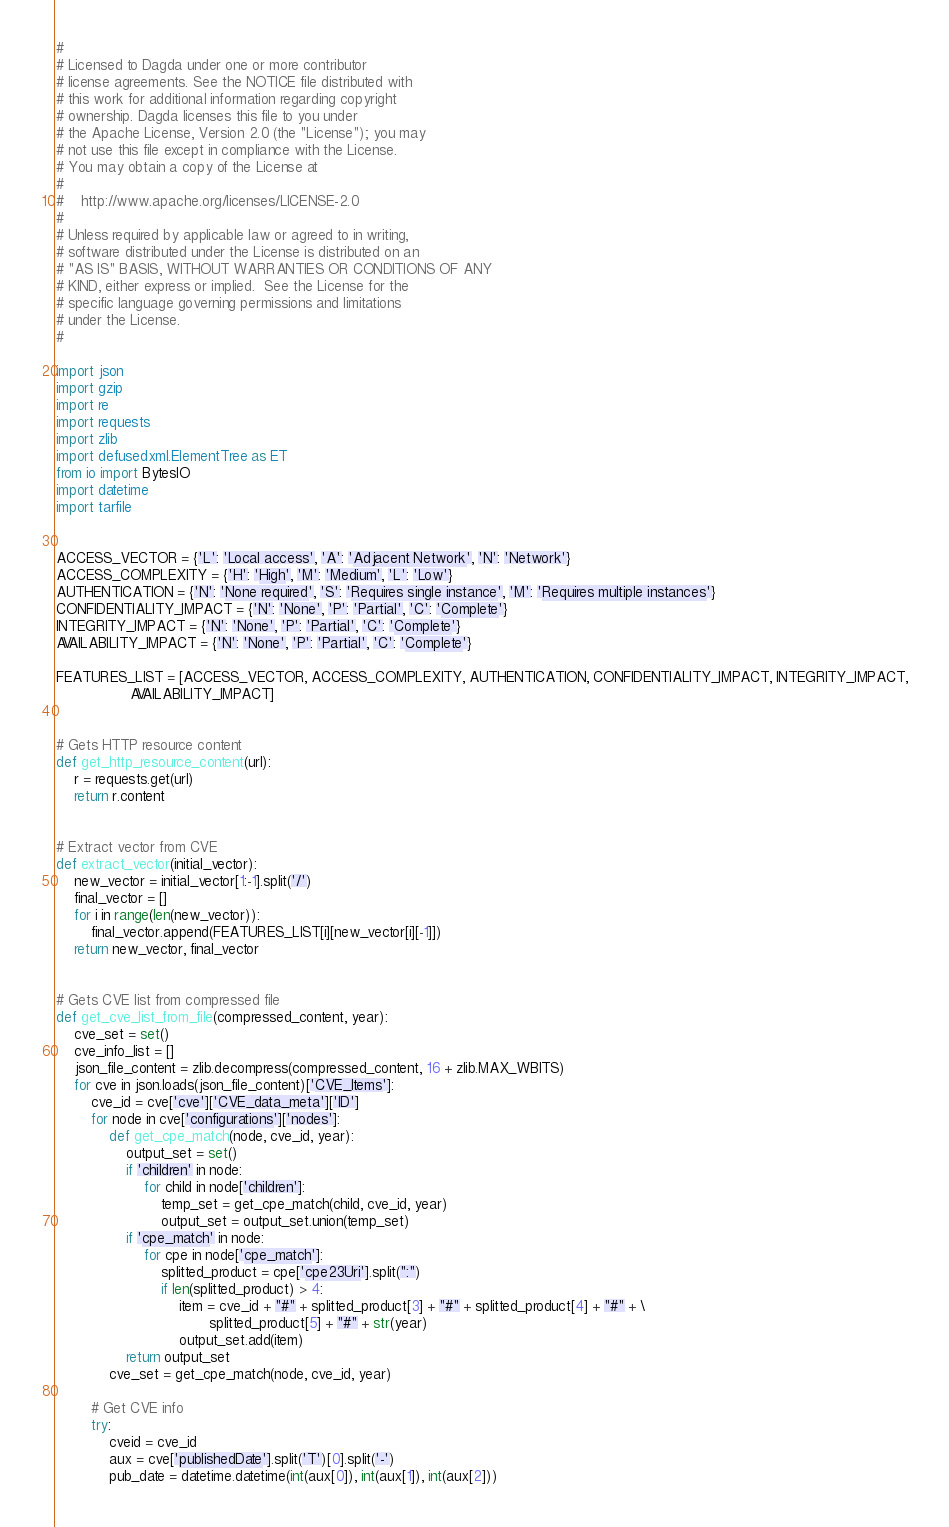Convert code to text. <code><loc_0><loc_0><loc_500><loc_500><_Python_>#
# Licensed to Dagda under one or more contributor
# license agreements. See the NOTICE file distributed with
# this work for additional information regarding copyright
# ownership. Dagda licenses this file to you under
# the Apache License, Version 2.0 (the "License"); you may
# not use this file except in compliance with the License.
# You may obtain a copy of the License at
#
#    http://www.apache.org/licenses/LICENSE-2.0
#
# Unless required by applicable law or agreed to in writing,
# software distributed under the License is distributed on an
# "AS IS" BASIS, WITHOUT WARRANTIES OR CONDITIONS OF ANY
# KIND, either express or implied.  See the License for the
# specific language governing permissions and limitations
# under the License.
#

import json
import gzip
import re
import requests
import zlib
import defusedxml.ElementTree as ET
from io import BytesIO
import datetime
import tarfile


ACCESS_VECTOR = {'L': 'Local access', 'A': 'Adjacent Network', 'N': 'Network'}
ACCESS_COMPLEXITY = {'H': 'High', 'M': 'Medium', 'L': 'Low'}
AUTHENTICATION = {'N': 'None required', 'S': 'Requires single instance', 'M': 'Requires multiple instances'}
CONFIDENTIALITY_IMPACT = {'N': 'None', 'P': 'Partial', 'C': 'Complete'}
INTEGRITY_IMPACT = {'N': 'None', 'P': 'Partial', 'C': 'Complete'}
AVAILABILITY_IMPACT = {'N': 'None', 'P': 'Partial', 'C': 'Complete'}

FEATURES_LIST = [ACCESS_VECTOR, ACCESS_COMPLEXITY, AUTHENTICATION, CONFIDENTIALITY_IMPACT, INTEGRITY_IMPACT,
                 AVAILABILITY_IMPACT]


# Gets HTTP resource content
def get_http_resource_content(url):
    r = requests.get(url)
    return r.content


# Extract vector from CVE
def extract_vector(initial_vector):
    new_vector = initial_vector[1:-1].split('/')
    final_vector = []
    for i in range(len(new_vector)):
        final_vector.append(FEATURES_LIST[i][new_vector[i][-1]])
    return new_vector, final_vector


# Gets CVE list from compressed file
def get_cve_list_from_file(compressed_content, year):
    cve_set = set()
    cve_info_list = []
    json_file_content = zlib.decompress(compressed_content, 16 + zlib.MAX_WBITS)
    for cve in json.loads(json_file_content)['CVE_Items']:
        cve_id = cve['cve']['CVE_data_meta']['ID']
        for node in cve['configurations']['nodes']:
            def get_cpe_match(node, cve_id, year):
                output_set = set()
                if 'children' in node:
                    for child in node['children']:
                        temp_set = get_cpe_match(child, cve_id, year)
                        output_set = output_set.union(temp_set)
                if 'cpe_match' in node:
                    for cpe in node['cpe_match']:
                        splitted_product = cpe['cpe23Uri'].split(":")
                        if len(splitted_product) > 4:
                            item = cve_id + "#" + splitted_product[3] + "#" + splitted_product[4] + "#" + \
                                   splitted_product[5] + "#" + str(year)
                            output_set.add(item)
                return output_set
            cve_set = get_cpe_match(node, cve_id, year)

        # Get CVE info
        try:
            cveid = cve_id
            aux = cve['publishedDate'].split('T')[0].split('-')
            pub_date = datetime.datetime(int(aux[0]), int(aux[1]), int(aux[2]))</code> 